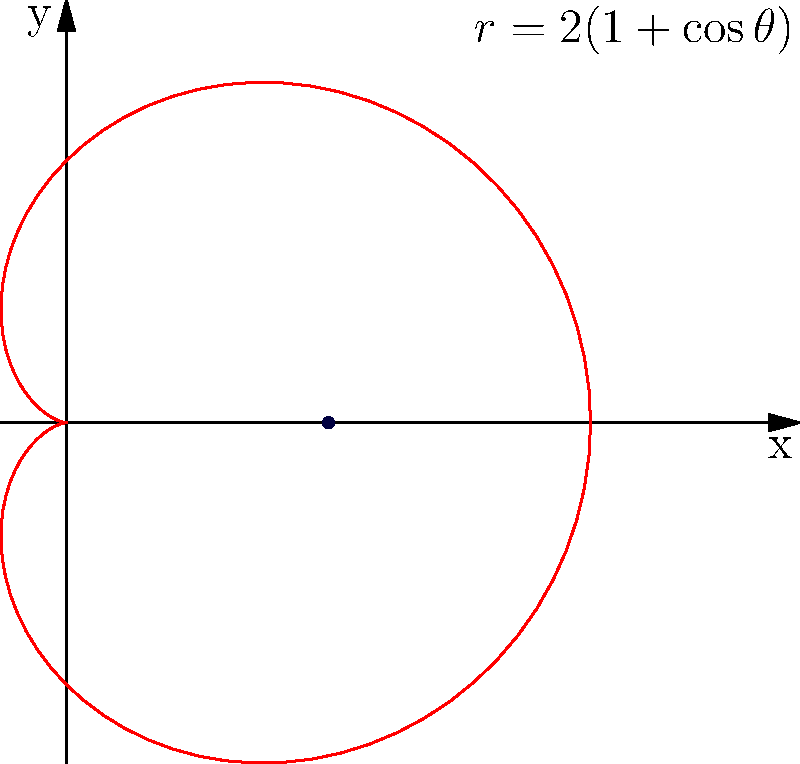Calculate the length of the cardioid given by the polar equation $r = 2(1 + \cos\theta)$. To find the length of the cardioid, we'll use the formula for arc length in polar coordinates:

$L = \int_0^{2\pi} \sqrt{r^2 + \left(\frac{dr}{d\theta}\right)^2} d\theta$

Step 1: Find $\frac{dr}{d\theta}$
$r = 2(1 + \cos\theta)$
$\frac{dr}{d\theta} = -2\sin\theta$

Step 2: Calculate $r^2 + \left(\frac{dr}{d\theta}\right)^2$
$r^2 = 4(1 + \cos\theta)^2 = 4(1 + 2\cos\theta + \cos^2\theta)$
$\left(\frac{dr}{d\theta}\right)^2 = 4\sin^2\theta$

$r^2 + \left(\frac{dr}{d\theta}\right)^2 = 4(1 + 2\cos\theta + \cos^2\theta + \sin^2\theta)$
$= 4(1 + 2\cos\theta + 1) = 8(1 + \cos\theta)$

Step 3: Simplify the integrand
$\sqrt{r^2 + \left(\frac{dr}{d\theta}\right)^2} = \sqrt{8(1 + \cos\theta)} = 2\sqrt{2}\sqrt{1 + \cos\theta}$

Step 4: Integrate
$L = \int_0^{2\pi} 2\sqrt{2}\sqrt{1 + \cos\theta} d\theta$

Let $u = \frac{\theta}{2}$, then $du = \frac{1}{2}d\theta$ and $\theta = 2u$

$L = 2\sqrt{2} \int_0^{\pi} \sqrt{1 + \cos(2u)} 2du$
$= 4\sqrt{2} \int_0^{\pi} \sqrt{2\cos^2u} du$
$= 4\sqrt{2} \int_0^{\pi} \sqrt{2}|\cos u| du$
$= 8 \int_0^{\pi} |\cos u| du = 16$

Therefore, the length of the cardioid is 16 units.
Answer: 16 